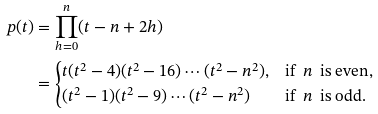<formula> <loc_0><loc_0><loc_500><loc_500>p ( t ) & = \prod _ { h = 0 } ^ { n } ( t - n + 2 h ) \\ & = \begin{cases} t ( t ^ { 2 } - 4 ) ( t ^ { 2 } - 1 6 ) \cdots ( t ^ { 2 } - n ^ { 2 } ) , & \text {if \ $n$ \ is even,} \\ ( t ^ { 2 } - 1 ) ( t ^ { 2 } - 9 ) \cdots ( t ^ { 2 } - n ^ { 2 } ) & \text {if \ $n$ \ is odd.} \end{cases}</formula> 